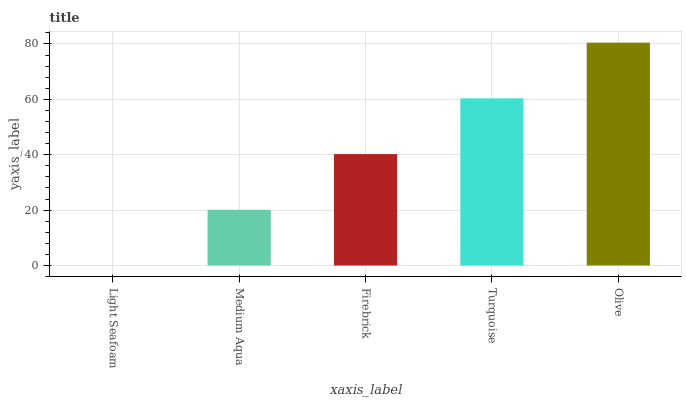Is Light Seafoam the minimum?
Answer yes or no. Yes. Is Olive the maximum?
Answer yes or no. Yes. Is Medium Aqua the minimum?
Answer yes or no. No. Is Medium Aqua the maximum?
Answer yes or no. No. Is Medium Aqua greater than Light Seafoam?
Answer yes or no. Yes. Is Light Seafoam less than Medium Aqua?
Answer yes or no. Yes. Is Light Seafoam greater than Medium Aqua?
Answer yes or no. No. Is Medium Aqua less than Light Seafoam?
Answer yes or no. No. Is Firebrick the high median?
Answer yes or no. Yes. Is Firebrick the low median?
Answer yes or no. Yes. Is Light Seafoam the high median?
Answer yes or no. No. Is Turquoise the low median?
Answer yes or no. No. 